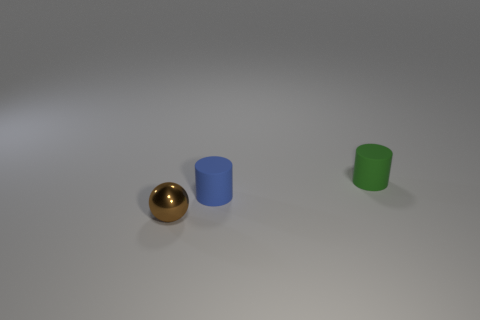Is the small cylinder that is on the left side of the green matte object made of the same material as the small sphere?
Offer a terse response. No. Is there anything else that has the same material as the brown sphere?
Keep it short and to the point. No. The rubber thing that is the same size as the green cylinder is what color?
Offer a terse response. Blue. Is there a tiny cylinder of the same color as the tiny metal object?
Make the answer very short. No. There is a cylinder that is made of the same material as the blue object; what size is it?
Your answer should be compact. Small. What number of other objects are there of the same size as the blue object?
Your answer should be compact. 2. What material is the thing that is right of the blue rubber thing?
Provide a succinct answer. Rubber. What is the shape of the thing that is to the left of the small rubber cylinder to the left of the thing that is on the right side of the small blue rubber cylinder?
Offer a terse response. Sphere. Does the green matte object have the same size as the blue cylinder?
Make the answer very short. Yes. How many things are either blue rubber cylinders or objects behind the tiny sphere?
Your answer should be very brief. 2. 